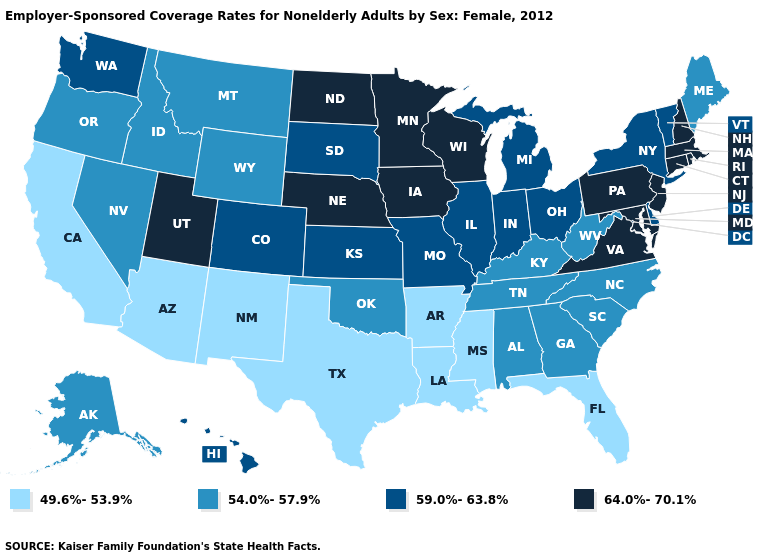What is the lowest value in states that border Minnesota?
Concise answer only. 59.0%-63.8%. Among the states that border New Jersey , does Delaware have the highest value?
Keep it brief. No. What is the value of Tennessee?
Give a very brief answer. 54.0%-57.9%. What is the lowest value in states that border Michigan?
Quick response, please. 59.0%-63.8%. Name the states that have a value in the range 59.0%-63.8%?
Write a very short answer. Colorado, Delaware, Hawaii, Illinois, Indiana, Kansas, Michigan, Missouri, New York, Ohio, South Dakota, Vermont, Washington. Which states have the lowest value in the USA?
Concise answer only. Arizona, Arkansas, California, Florida, Louisiana, Mississippi, New Mexico, Texas. Is the legend a continuous bar?
Short answer required. No. Name the states that have a value in the range 59.0%-63.8%?
Quick response, please. Colorado, Delaware, Hawaii, Illinois, Indiana, Kansas, Michigan, Missouri, New York, Ohio, South Dakota, Vermont, Washington. How many symbols are there in the legend?
Short answer required. 4. What is the value of New York?
Short answer required. 59.0%-63.8%. Does Connecticut have a higher value than Florida?
Short answer required. Yes. Does Rhode Island have the highest value in the USA?
Short answer required. Yes. What is the value of North Dakota?
Short answer required. 64.0%-70.1%. Name the states that have a value in the range 59.0%-63.8%?
Concise answer only. Colorado, Delaware, Hawaii, Illinois, Indiana, Kansas, Michigan, Missouri, New York, Ohio, South Dakota, Vermont, Washington. Name the states that have a value in the range 64.0%-70.1%?
Concise answer only. Connecticut, Iowa, Maryland, Massachusetts, Minnesota, Nebraska, New Hampshire, New Jersey, North Dakota, Pennsylvania, Rhode Island, Utah, Virginia, Wisconsin. 